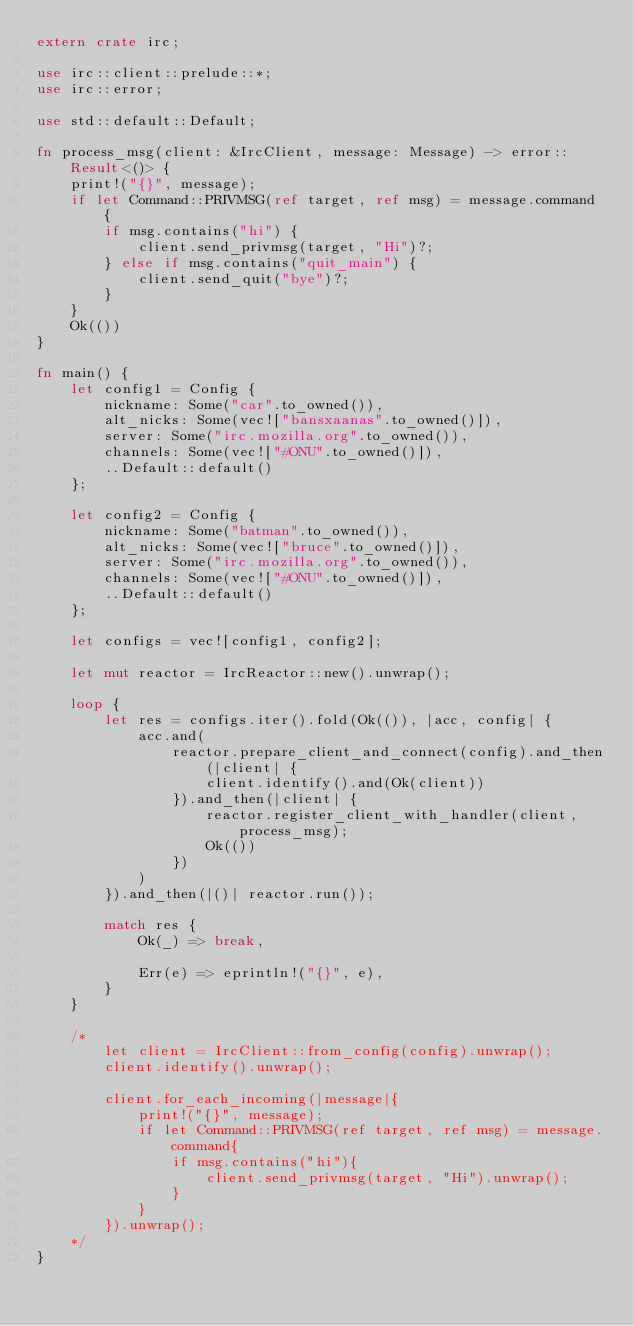Convert code to text. <code><loc_0><loc_0><loc_500><loc_500><_Rust_>extern crate irc;

use irc::client::prelude::*;
use irc::error;

use std::default::Default;

fn process_msg(client: &IrcClient, message: Message) -> error::Result<()> {
    print!("{}", message);
    if let Command::PRIVMSG(ref target, ref msg) = message.command {
        if msg.contains("hi") {
            client.send_privmsg(target, "Hi")?;
        } else if msg.contains("quit_main") {
            client.send_quit("bye")?;
        }
    }
    Ok(())
}

fn main() {
    let config1 = Config {
        nickname: Some("car".to_owned()),
        alt_nicks: Some(vec!["bansxaanas".to_owned()]),
        server: Some("irc.mozilla.org".to_owned()),
        channels: Some(vec!["#ONU".to_owned()]),
        ..Default::default()
    };

    let config2 = Config {
        nickname: Some("batman".to_owned()),
        alt_nicks: Some(vec!["bruce".to_owned()]),
        server: Some("irc.mozilla.org".to_owned()),
        channels: Some(vec!["#ONU".to_owned()]),
        ..Default::default()
    };

    let configs = vec![config1, config2];

    let mut reactor = IrcReactor::new().unwrap();

    loop {
        let res = configs.iter().fold(Ok(()), |acc, config| {
            acc.and(
                reactor.prepare_client_and_connect(config).and_then(|client| {
                    client.identify().and(Ok(client))
                }).and_then(|client| {
                    reactor.register_client_with_handler(client, process_msg);
                    Ok(())
                })
            )
        }).and_then(|()| reactor.run());

        match res {
            Ok(_) => break,

            Err(e) => eprintln!("{}", e),
        }
    }

    /*
        let client = IrcClient::from_config(config).unwrap();
        client.identify().unwrap();

        client.for_each_incoming(|message|{
            print!("{}", message);
            if let Command::PRIVMSG(ref target, ref msg) = message.command{
                if msg.contains("hi"){
                    client.send_privmsg(target, "Hi").unwrap();
                }
            }
        }).unwrap();
    */
}
</code> 